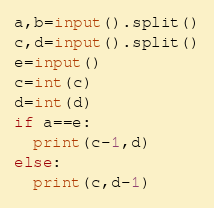Convert code to text. <code><loc_0><loc_0><loc_500><loc_500><_Python_>a,b=input().split()
c,d=input().split()
e=input()
c=int(c)
d=int(d)
if a==e:
  print(c-1,d)
else:
  print(c,d-1)</code> 